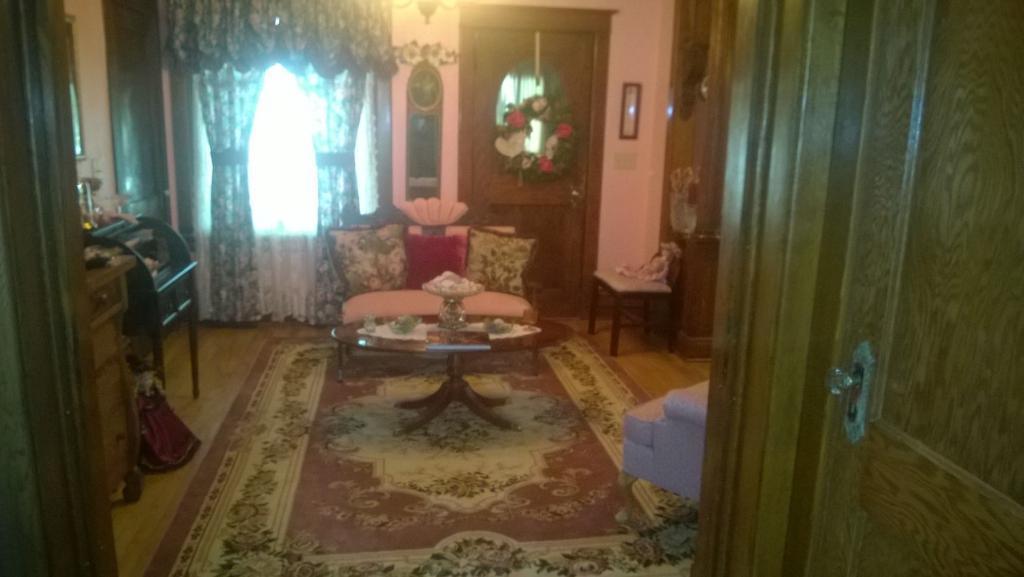Describe this image in one or two sentences. In the image in the center we can see sofa,carpet and table. On the table,we can see flower vase,bowl,flower vase and few other objects. On the right side there is a door. In the background we can see a wall,door,mirror,flower garland,curtain,window,table,bag,chairs,toy,light and few other objects. 